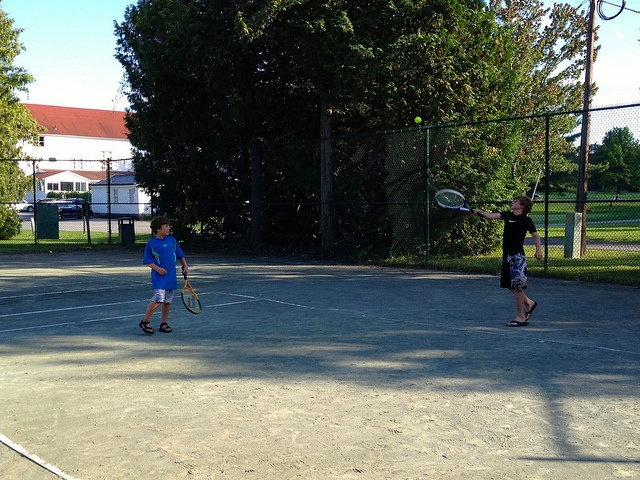Describe the objects in this image and their specific colors. I can see people in gray, darkblue, black, navy, and blue tones, people in gray, black, and navy tones, tennis racket in gray, blue, black, and darkblue tones, tennis racket in gray, black, purple, and navy tones, and car in gray, black, navy, and darkblue tones in this image. 